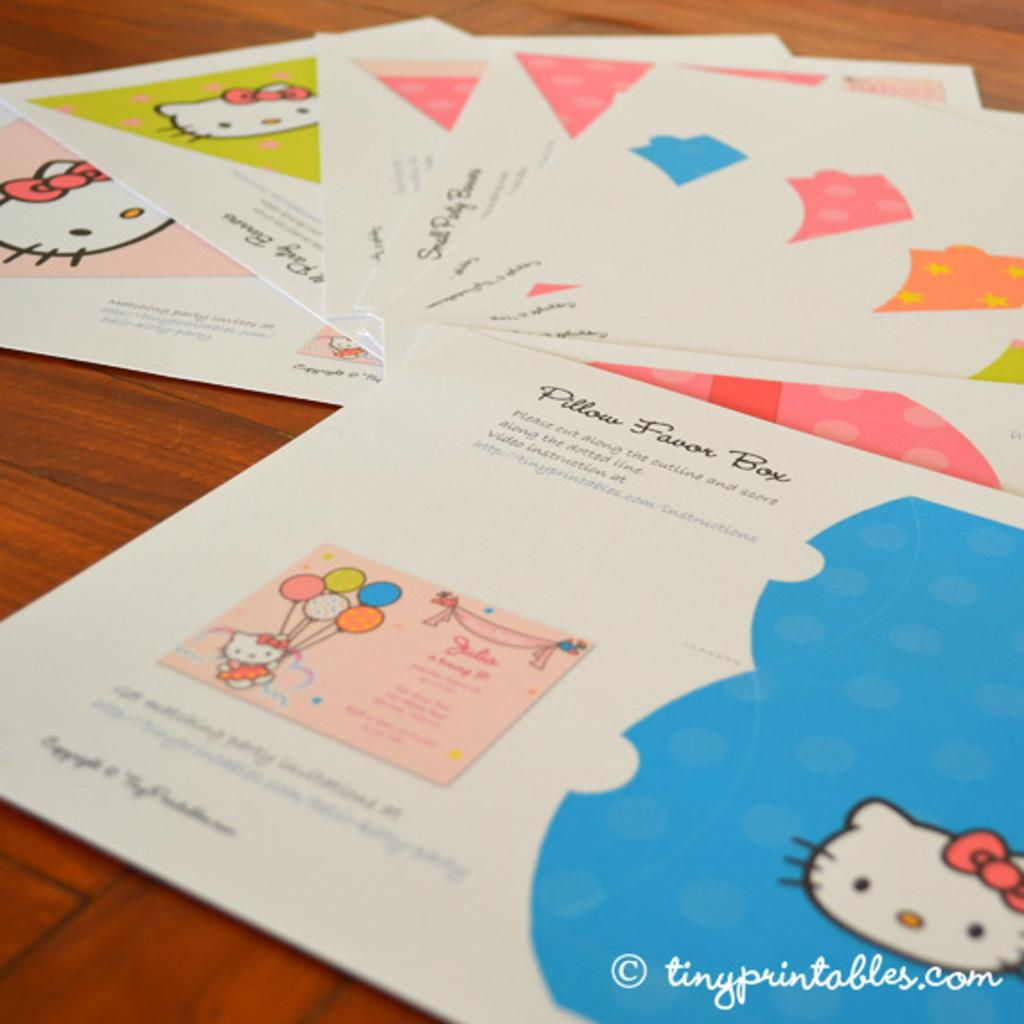<image>
Share a concise interpretation of the image provided. Some pages spread out on a table and one has the words, pillow favor box, on it. 